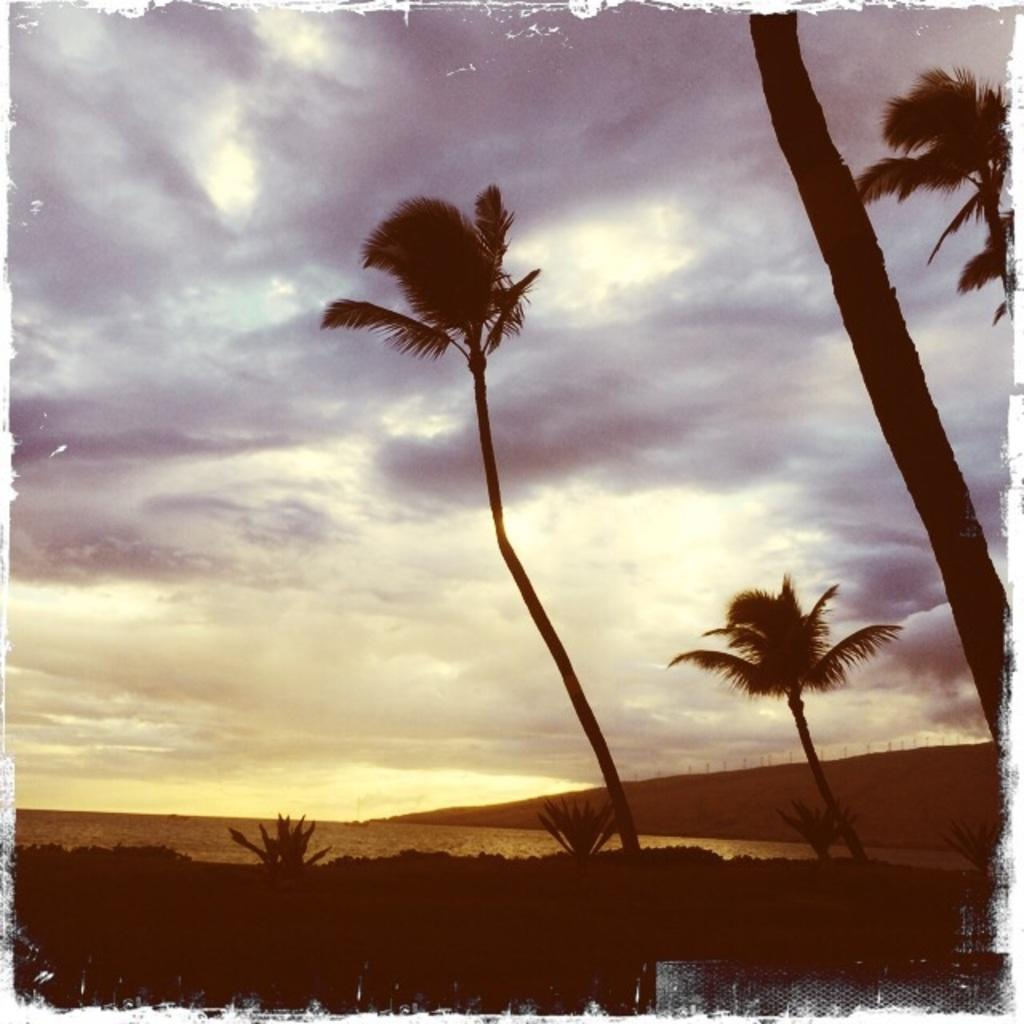What type of vegetation can be seen in the image? There are trees in the image. What type of terrain is visible in the image? There is sand visible in the image. What type of brass instrument is being played in the image? There is no brass instrument present in the image; it only features trees and sand. What type of art can be seen in the image? There is no art present in the image; it only features trees and sand. 